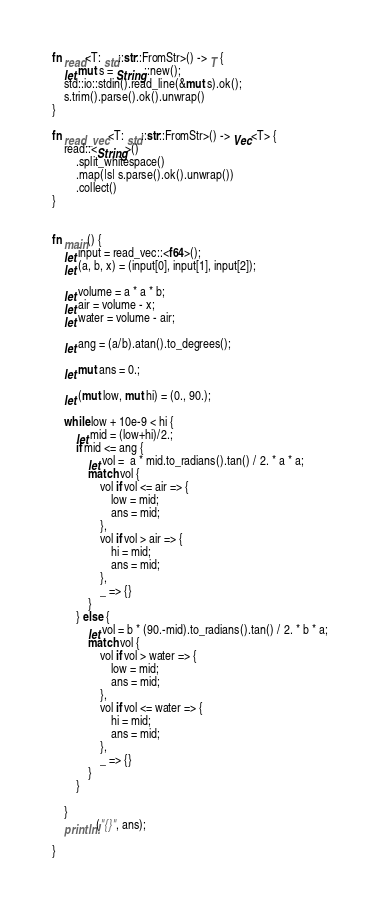Convert code to text. <code><loc_0><loc_0><loc_500><loc_500><_Rust_>fn read<T: std::str::FromStr>() -> T {
    let mut s = String::new();
    std::io::stdin().read_line(&mut s).ok();
    s.trim().parse().ok().unwrap()
}

fn read_vec<T: std::str::FromStr>() -> Vec<T> {
    read::<String>()
        .split_whitespace()
        .map(|s| s.parse().ok().unwrap())
        .collect()
}


fn main() {
    let input = read_vec::<f64>();
    let (a, b, x) = (input[0], input[1], input[2]);

    let volume = a * a * b;
    let air = volume - x;
    let water = volume - air;

    let ang = (a/b).atan().to_degrees();

    let mut ans = 0.;
    
    let (mut low, mut hi) = (0., 90.);

    while low + 10e-9 < hi {
        let mid = (low+hi)/2.;
        if mid <= ang {
            let vol =  a * mid.to_radians().tan() / 2. * a * a;
            match vol {
                vol if vol <= air => {
                    low = mid;
                    ans = mid;
                },
                vol if vol > air => {
                    hi = mid;
                    ans = mid;
                },
                _ => {}
            }
        } else {
            let vol = b * (90.-mid).to_radians().tan() / 2. * b * a;
            match vol {
                vol if vol > water => {
                    low = mid;
                    ans = mid;
                },
                vol if vol <= water => {
                    hi = mid;
                    ans = mid;
                },
                _ => {}
            }
        }
        
    }
    println!("{}", ans);

}</code> 